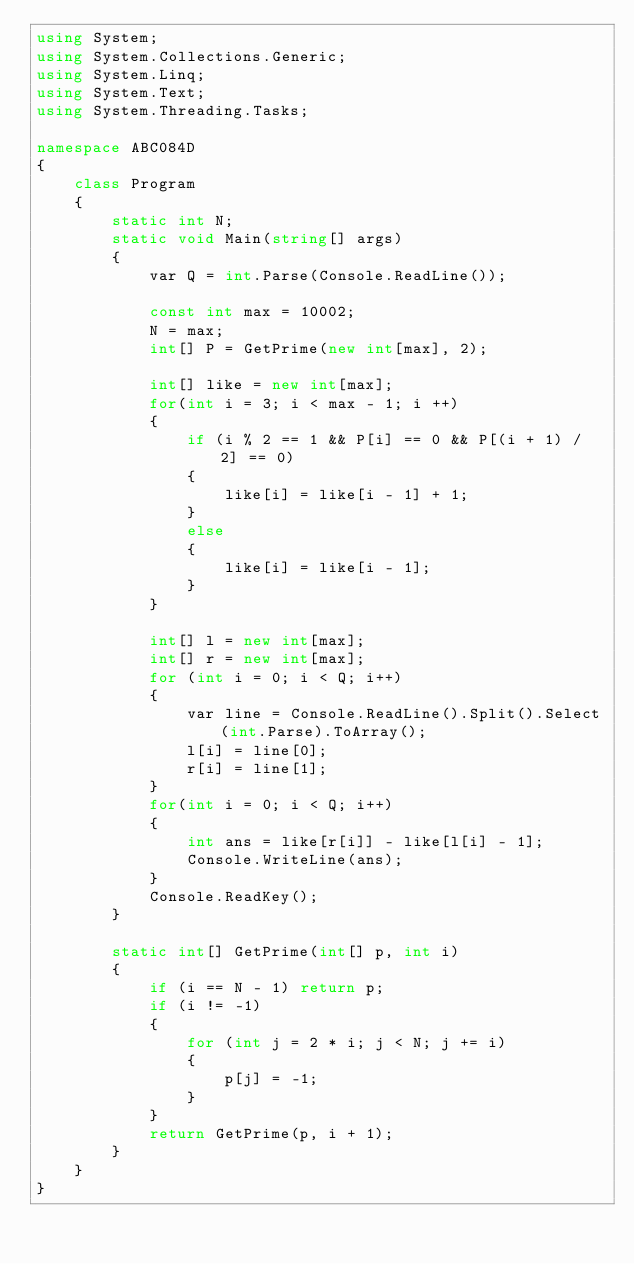Convert code to text. <code><loc_0><loc_0><loc_500><loc_500><_C#_>using System;
using System.Collections.Generic;
using System.Linq;
using System.Text;
using System.Threading.Tasks;

namespace ABC084D
{
    class Program
    {
        static int N;
        static void Main(string[] args)
        {
            var Q = int.Parse(Console.ReadLine());

            const int max = 10002;
            N = max;
            int[] P = GetPrime(new int[max], 2);

            int[] like = new int[max];
            for(int i = 3; i < max - 1; i ++)
            {
                if (i % 2 == 1 && P[i] == 0 && P[(i + 1) / 2] == 0)
                {
                    like[i] = like[i - 1] + 1;
                }
                else
                {
                    like[i] = like[i - 1];
                }
            }

            int[] l = new int[max];
            int[] r = new int[max];
            for (int i = 0; i < Q; i++)
            {
                var line = Console.ReadLine().Split().Select(int.Parse).ToArray();
                l[i] = line[0];
                r[i] = line[1];
            }
            for(int i = 0; i < Q; i++)
            {
                int ans = like[r[i]] - like[l[i] - 1];
                Console.WriteLine(ans);
            }
            Console.ReadKey();
        }

        static int[] GetPrime(int[] p, int i)
        {
            if (i == N - 1) return p;
            if (i != -1)
            {
                for (int j = 2 * i; j < N; j += i)
                {
                    p[j] = -1;
                }
            }
            return GetPrime(p, i + 1);
        }
    }
}
</code> 